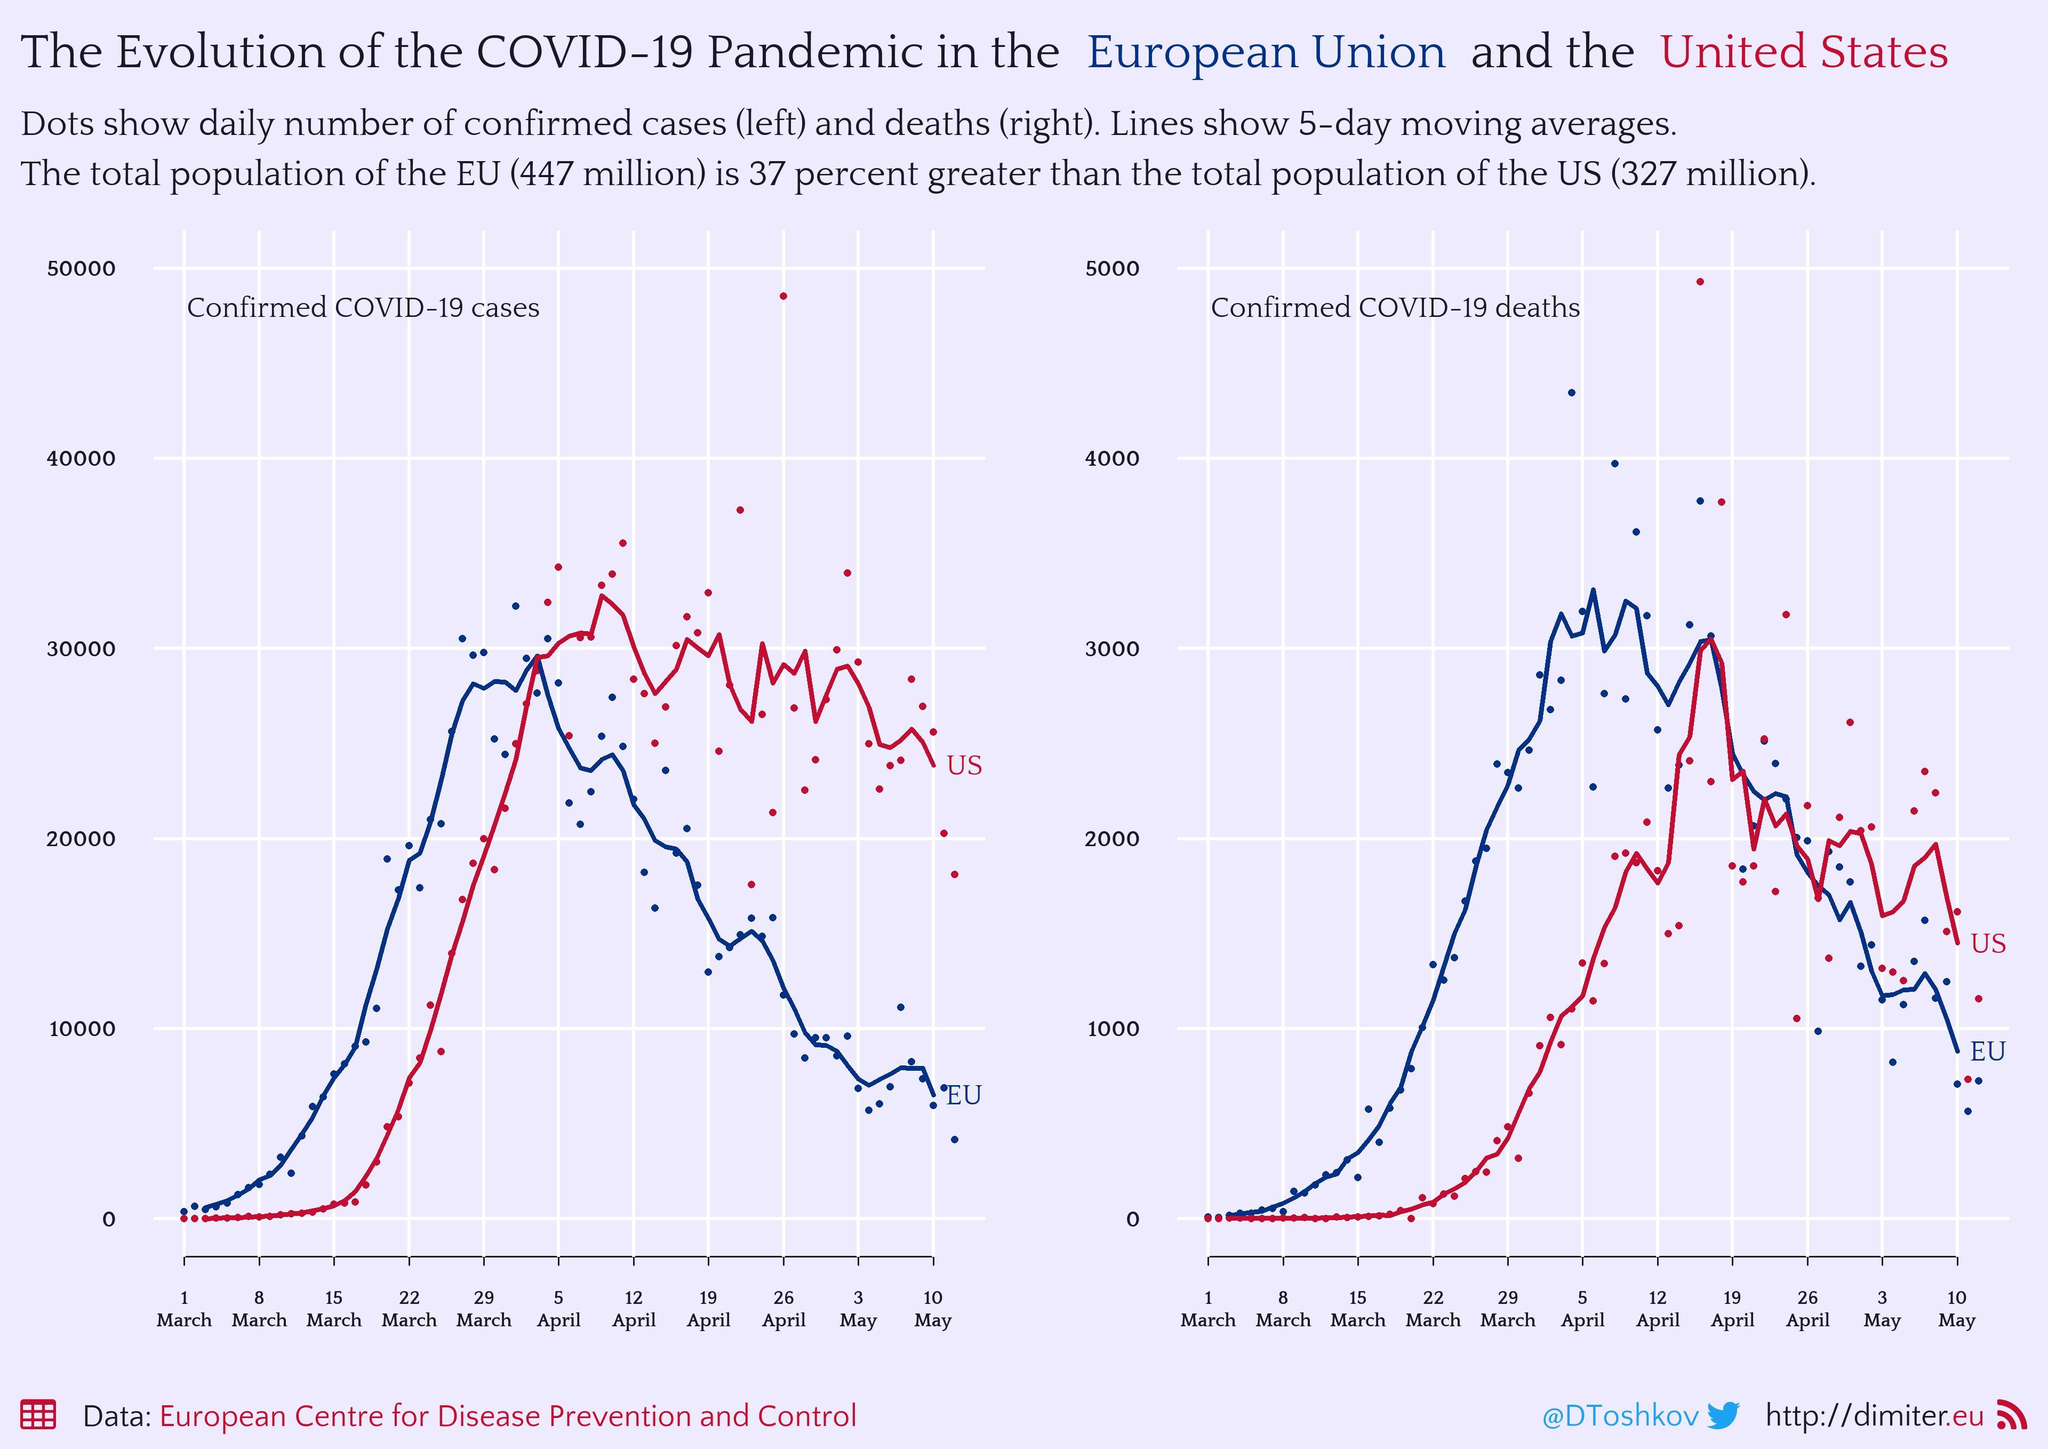In which month was the highest death reported in EU
Answer the question with a short phrase. April Red line is for which country US Blue line is for which region European Union In which month was the highest death reported in US April In which month was the case the highest in US April 